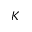<formula> <loc_0><loc_0><loc_500><loc_500>K</formula> 